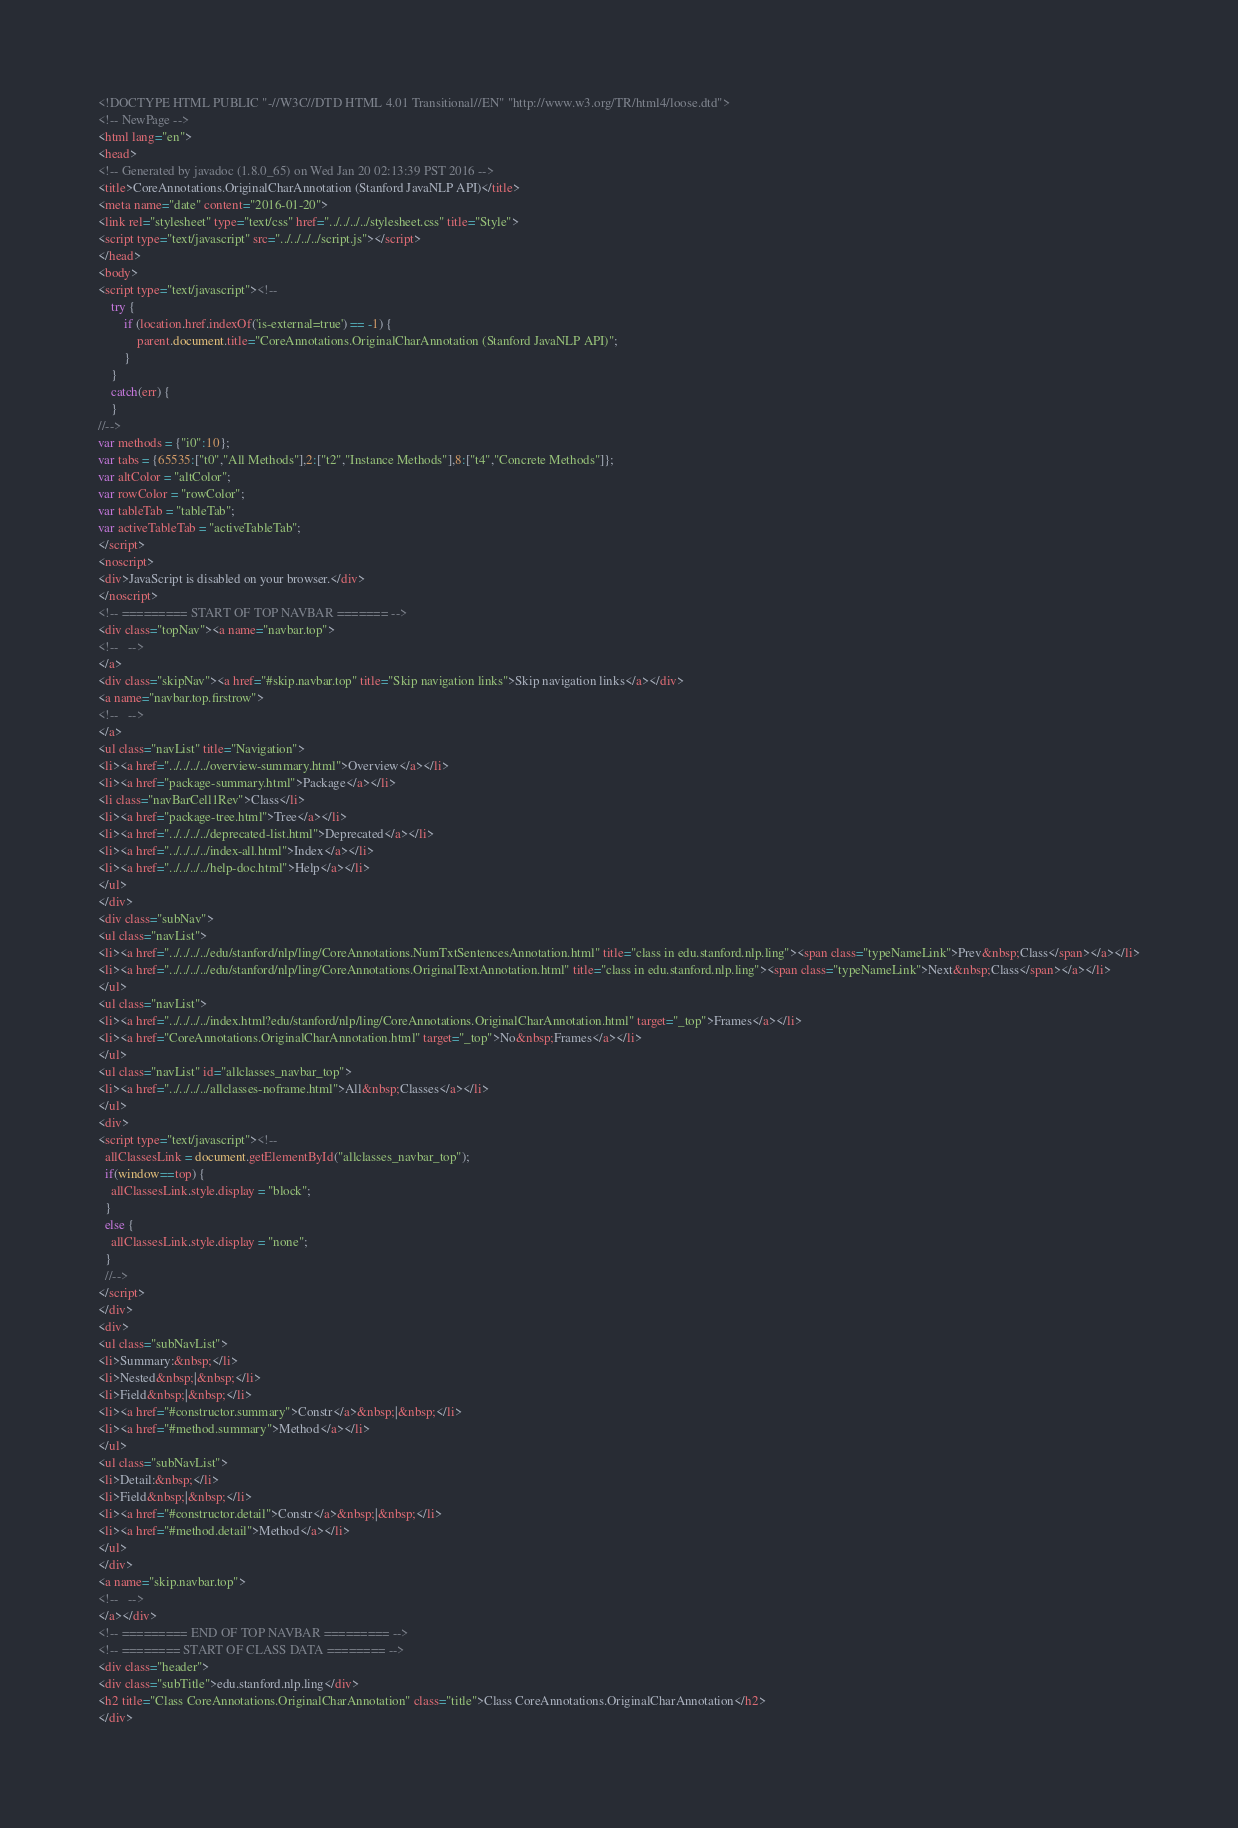Convert code to text. <code><loc_0><loc_0><loc_500><loc_500><_HTML_><!DOCTYPE HTML PUBLIC "-//W3C//DTD HTML 4.01 Transitional//EN" "http://www.w3.org/TR/html4/loose.dtd">
<!-- NewPage -->
<html lang="en">
<head>
<!-- Generated by javadoc (1.8.0_65) on Wed Jan 20 02:13:39 PST 2016 -->
<title>CoreAnnotations.OriginalCharAnnotation (Stanford JavaNLP API)</title>
<meta name="date" content="2016-01-20">
<link rel="stylesheet" type="text/css" href="../../../../stylesheet.css" title="Style">
<script type="text/javascript" src="../../../../script.js"></script>
</head>
<body>
<script type="text/javascript"><!--
    try {
        if (location.href.indexOf('is-external=true') == -1) {
            parent.document.title="CoreAnnotations.OriginalCharAnnotation (Stanford JavaNLP API)";
        }
    }
    catch(err) {
    }
//-->
var methods = {"i0":10};
var tabs = {65535:["t0","All Methods"],2:["t2","Instance Methods"],8:["t4","Concrete Methods"]};
var altColor = "altColor";
var rowColor = "rowColor";
var tableTab = "tableTab";
var activeTableTab = "activeTableTab";
</script>
<noscript>
<div>JavaScript is disabled on your browser.</div>
</noscript>
<!-- ========= START OF TOP NAVBAR ======= -->
<div class="topNav"><a name="navbar.top">
<!--   -->
</a>
<div class="skipNav"><a href="#skip.navbar.top" title="Skip navigation links">Skip navigation links</a></div>
<a name="navbar.top.firstrow">
<!--   -->
</a>
<ul class="navList" title="Navigation">
<li><a href="../../../../overview-summary.html">Overview</a></li>
<li><a href="package-summary.html">Package</a></li>
<li class="navBarCell1Rev">Class</li>
<li><a href="package-tree.html">Tree</a></li>
<li><a href="../../../../deprecated-list.html">Deprecated</a></li>
<li><a href="../../../../index-all.html">Index</a></li>
<li><a href="../../../../help-doc.html">Help</a></li>
</ul>
</div>
<div class="subNav">
<ul class="navList">
<li><a href="../../../../edu/stanford/nlp/ling/CoreAnnotations.NumTxtSentencesAnnotation.html" title="class in edu.stanford.nlp.ling"><span class="typeNameLink">Prev&nbsp;Class</span></a></li>
<li><a href="../../../../edu/stanford/nlp/ling/CoreAnnotations.OriginalTextAnnotation.html" title="class in edu.stanford.nlp.ling"><span class="typeNameLink">Next&nbsp;Class</span></a></li>
</ul>
<ul class="navList">
<li><a href="../../../../index.html?edu/stanford/nlp/ling/CoreAnnotations.OriginalCharAnnotation.html" target="_top">Frames</a></li>
<li><a href="CoreAnnotations.OriginalCharAnnotation.html" target="_top">No&nbsp;Frames</a></li>
</ul>
<ul class="navList" id="allclasses_navbar_top">
<li><a href="../../../../allclasses-noframe.html">All&nbsp;Classes</a></li>
</ul>
<div>
<script type="text/javascript"><!--
  allClassesLink = document.getElementById("allclasses_navbar_top");
  if(window==top) {
    allClassesLink.style.display = "block";
  }
  else {
    allClassesLink.style.display = "none";
  }
  //-->
</script>
</div>
<div>
<ul class="subNavList">
<li>Summary:&nbsp;</li>
<li>Nested&nbsp;|&nbsp;</li>
<li>Field&nbsp;|&nbsp;</li>
<li><a href="#constructor.summary">Constr</a>&nbsp;|&nbsp;</li>
<li><a href="#method.summary">Method</a></li>
</ul>
<ul class="subNavList">
<li>Detail:&nbsp;</li>
<li>Field&nbsp;|&nbsp;</li>
<li><a href="#constructor.detail">Constr</a>&nbsp;|&nbsp;</li>
<li><a href="#method.detail">Method</a></li>
</ul>
</div>
<a name="skip.navbar.top">
<!--   -->
</a></div>
<!-- ========= END OF TOP NAVBAR ========= -->
<!-- ======== START OF CLASS DATA ======== -->
<div class="header">
<div class="subTitle">edu.stanford.nlp.ling</div>
<h2 title="Class CoreAnnotations.OriginalCharAnnotation" class="title">Class CoreAnnotations.OriginalCharAnnotation</h2>
</div></code> 